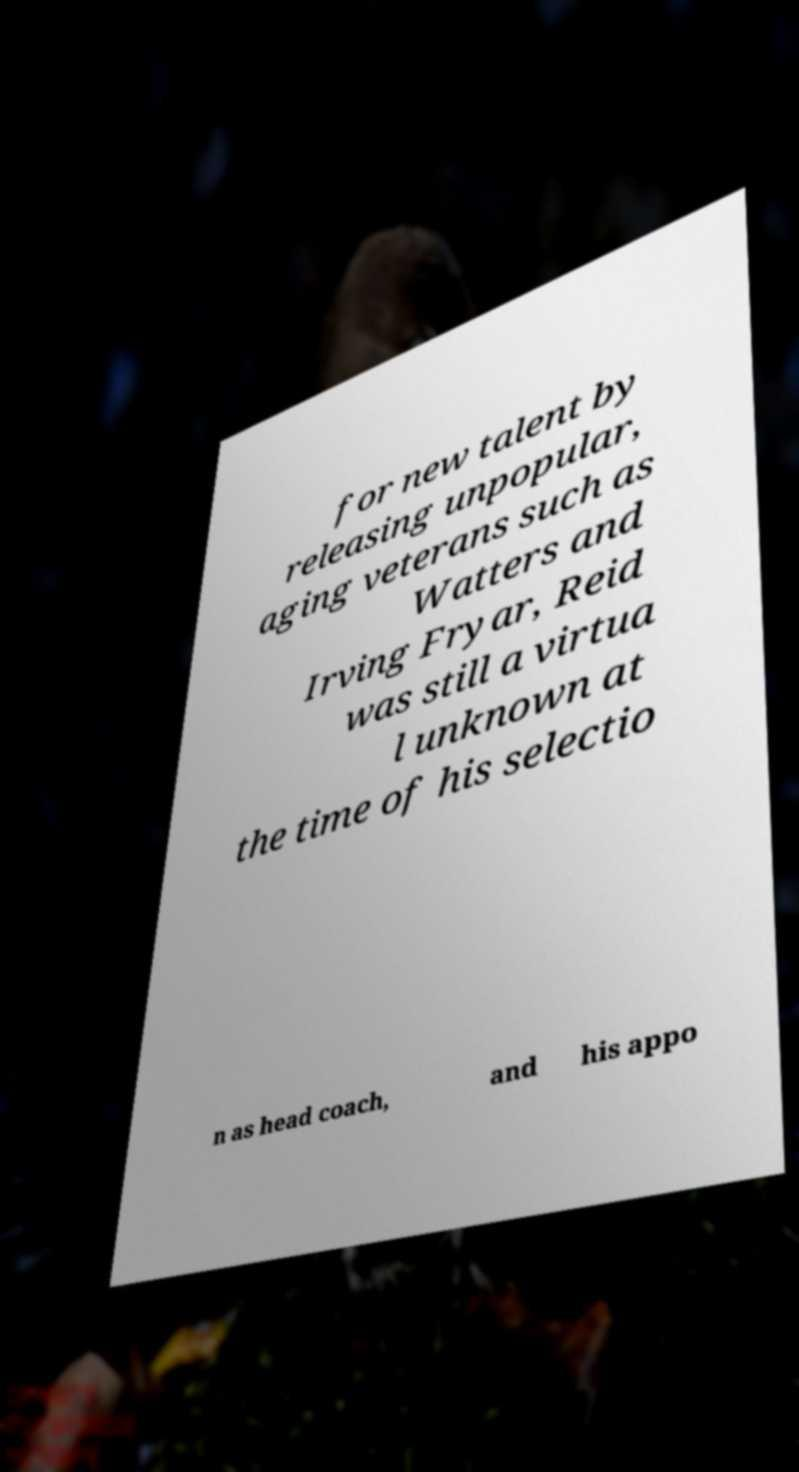Please identify and transcribe the text found in this image. for new talent by releasing unpopular, aging veterans such as Watters and Irving Fryar, Reid was still a virtua l unknown at the time of his selectio n as head coach, and his appo 